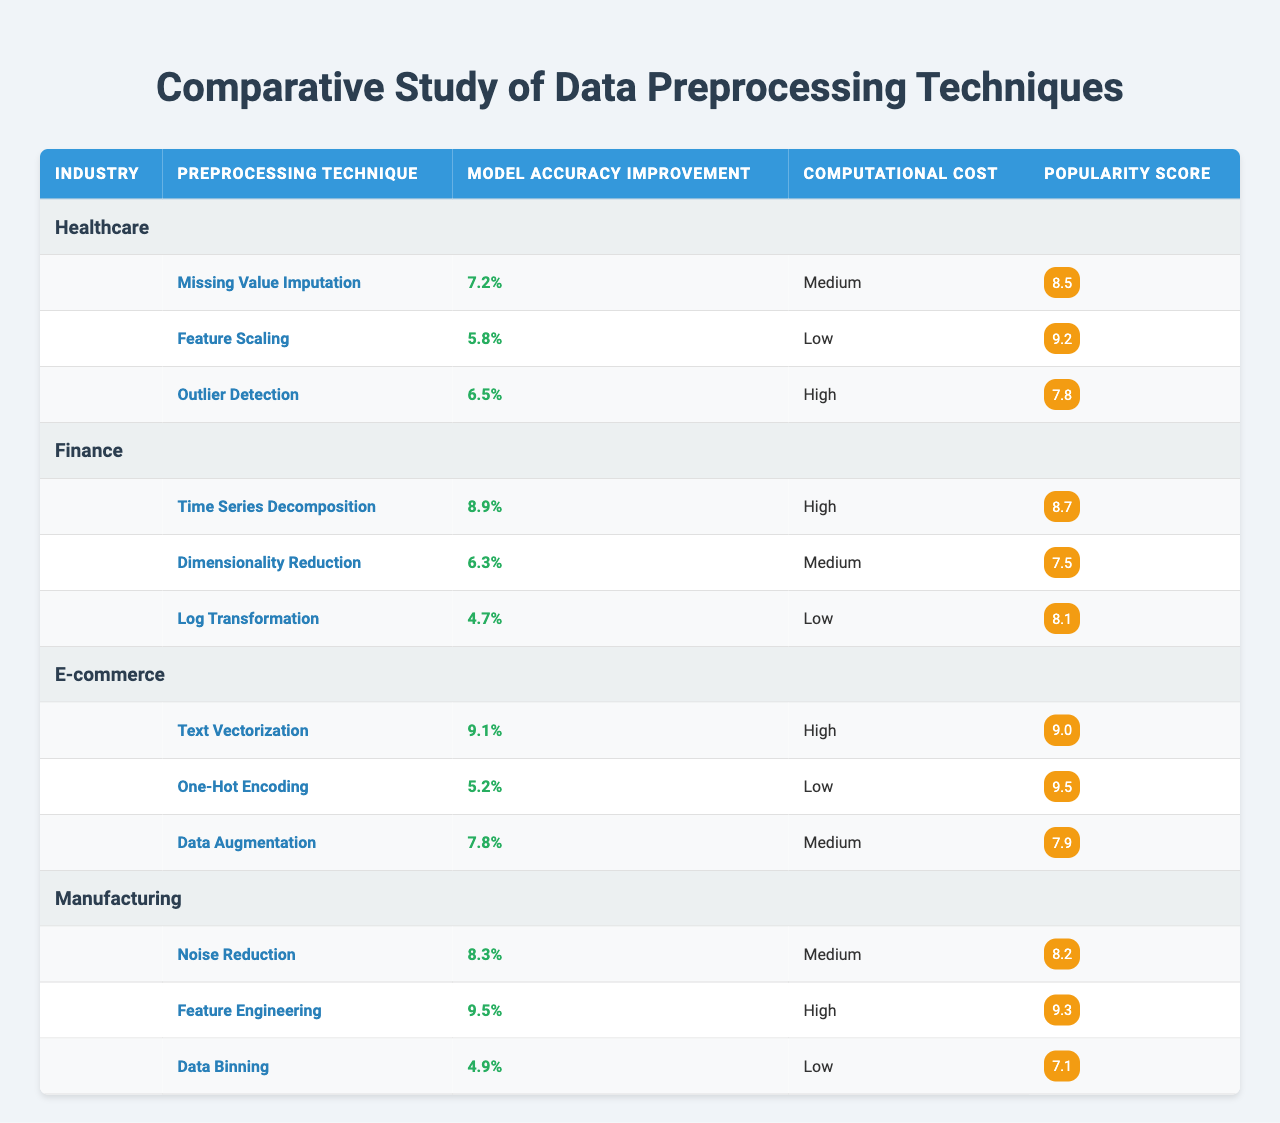What is the model accuracy improvement for the "Noise Reduction" technique in Manufacturing? By locating the "Manufacturing" section in the table and finding the "Noise Reduction" technique, we see that its model accuracy improvement is 8.3%.
Answer: 8.3% Which preprocessing technique has the highest popularity score in Healthcare? In the Healthcare section, the techniques listed along with their popularity scores are: Missing Value Imputation (8.5), Feature Scaling (9.2), and Outlier Detection (7.8). The highest is Feature Scaling with a score of 9.2.
Answer: Feature Scaling What is the average model accuracy improvement across the E-commerce industry? The techniques for E-commerce are: Text Vectorization (9.1%), One-Hot Encoding (5.2%), and Data Augmentation (7.8%). The average is (9.1 + 5.2 + 7.8) / 3 = 7.36%.
Answer: 7.36% Is the computational cost of "Time Series Decomposition" in Finance categorized as high? In the Finance section, "Time Series Decomposition" has a computational cost marked as High. Thus, the statement is true.
Answer: Yes Which industry benefits the most from Feature Engineering in terms of model accuracy improvement and by how much? Looking at the Manufacturing industry, Feature Engineering shows a model accuracy improvement of 9.5%, which is higher than any other industry or technique listed in the table.
Answer: 9.5% What is the computational cost of the least popular technique in Healthcare? The techniques in Healthcare with their popularity scores are: Missing Value Imputation (8.5), Feature Scaling (9.2), and Outlier Detection (7.8). The least popular is Outlier Detection with a popularity score of 7.8, and its computational cost is High.
Answer: High If we sum the model accuracy improvements for all preprocessing techniques in the Finance industry, what is the total? The technique model accuracy improvements for Finance are: Time Series Decomposition (8.9%), Dimensionality Reduction (6.3%), and Log Transformation (4.7%). By summing these: 8.9 + 6.3 + 4.7 = 19.9%.
Answer: 19.9% Which preprocessing technique exhibits the lowest model accuracy improvement across all industries? Analyzing the table, the lowest accuracy improvement is from Log Transformation in Finance, which shows a 4.7% improvement.
Answer: 4.7% Is it true that all techniques in the E-commerce industry have a computational cost of High? The table shows that Text Vectorization and Data Augmentation have a High cost while One-Hot Encoding is Low, making the statement false.
Answer: No What can you conclude about the popularity of the techniques in Manufacturing compared to Healthcare? Comparing Manufacturing and Healthcare, the techniques in Manufacturing have popularity scores ranging from 7.1 to 9.3, while in Healthcare, they range from 7.8 to 9.2. The maximum in Manufacturing (9.3) is higher than Healthcare's maximum (9.2), indicating that Manufacturing's techniques are generally more popular.
Answer: Manufacturing techniques are more popular 